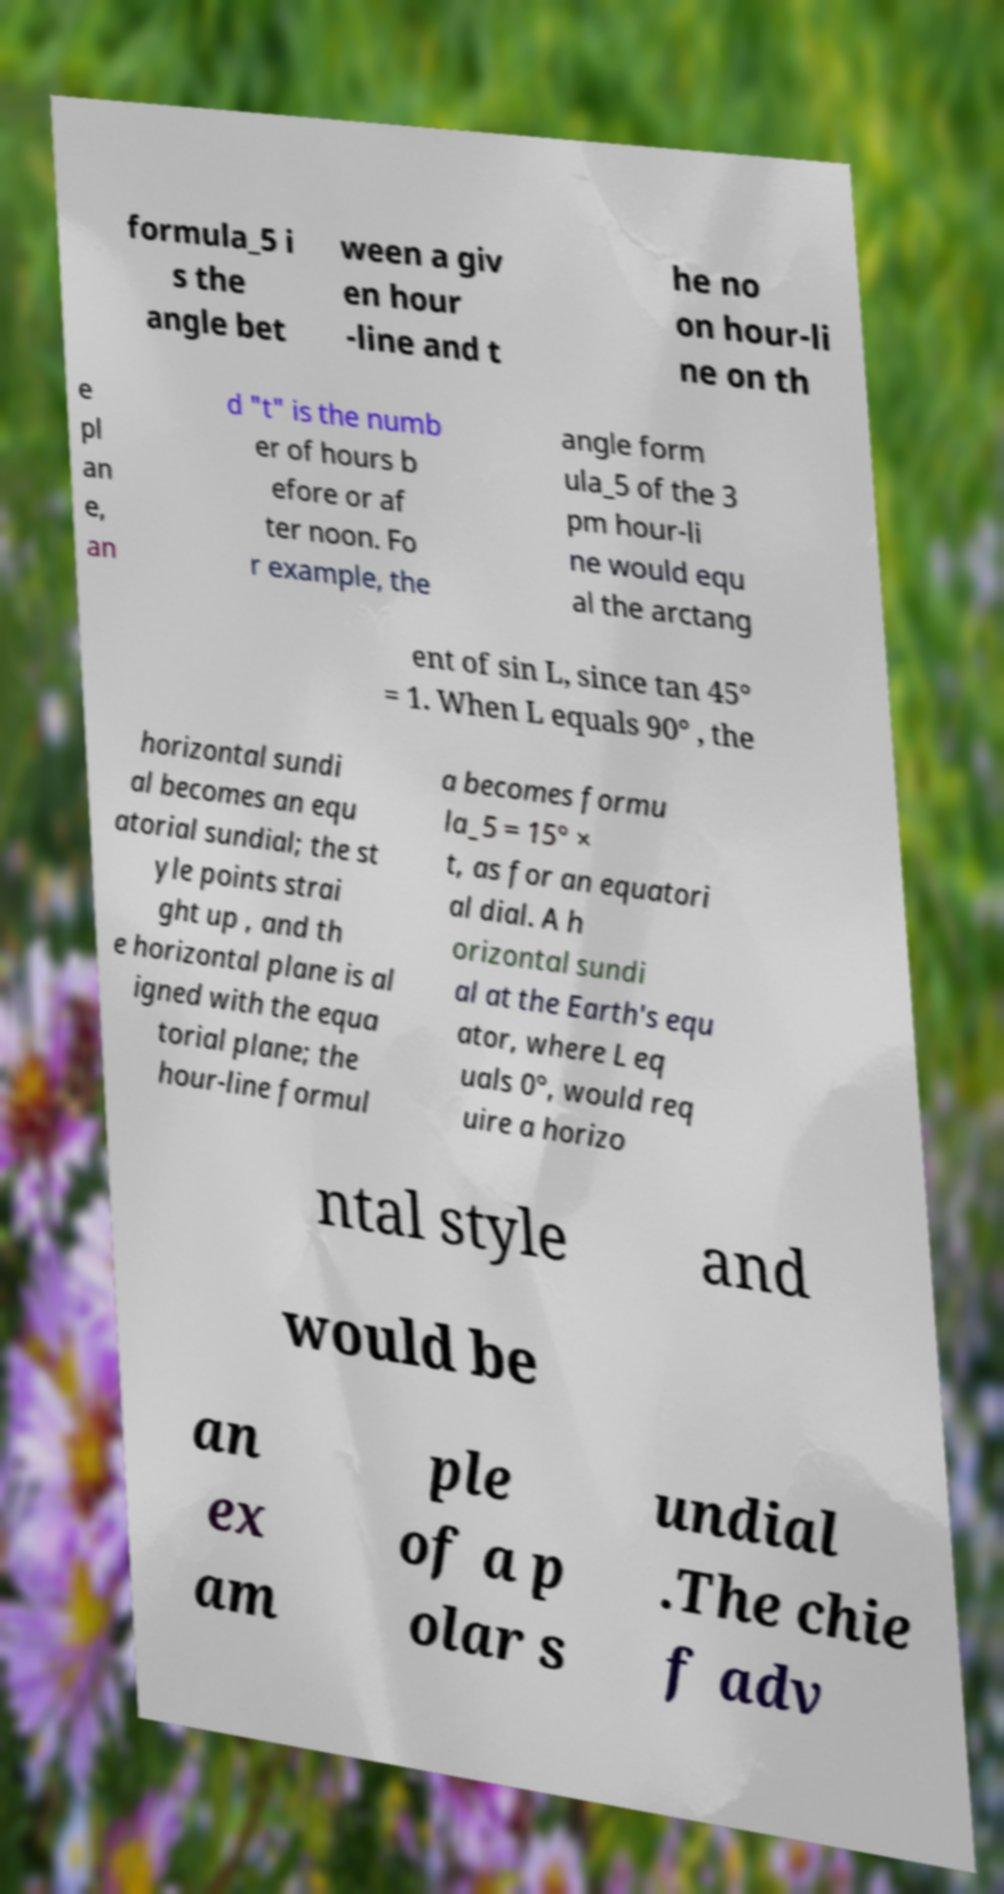Could you extract and type out the text from this image? formula_5 i s the angle bet ween a giv en hour -line and t he no on hour-li ne on th e pl an e, an d "t" is the numb er of hours b efore or af ter noon. Fo r example, the angle form ula_5 of the 3 pm hour-li ne would equ al the arctang ent of sin L, since tan 45° = 1. When L equals 90° , the horizontal sundi al becomes an equ atorial sundial; the st yle points strai ght up , and th e horizontal plane is al igned with the equa torial plane; the hour-line formul a becomes formu la_5 = 15° × t, as for an equatori al dial. A h orizontal sundi al at the Earth's equ ator, where L eq uals 0°, would req uire a horizo ntal style and would be an ex am ple of a p olar s undial .The chie f adv 